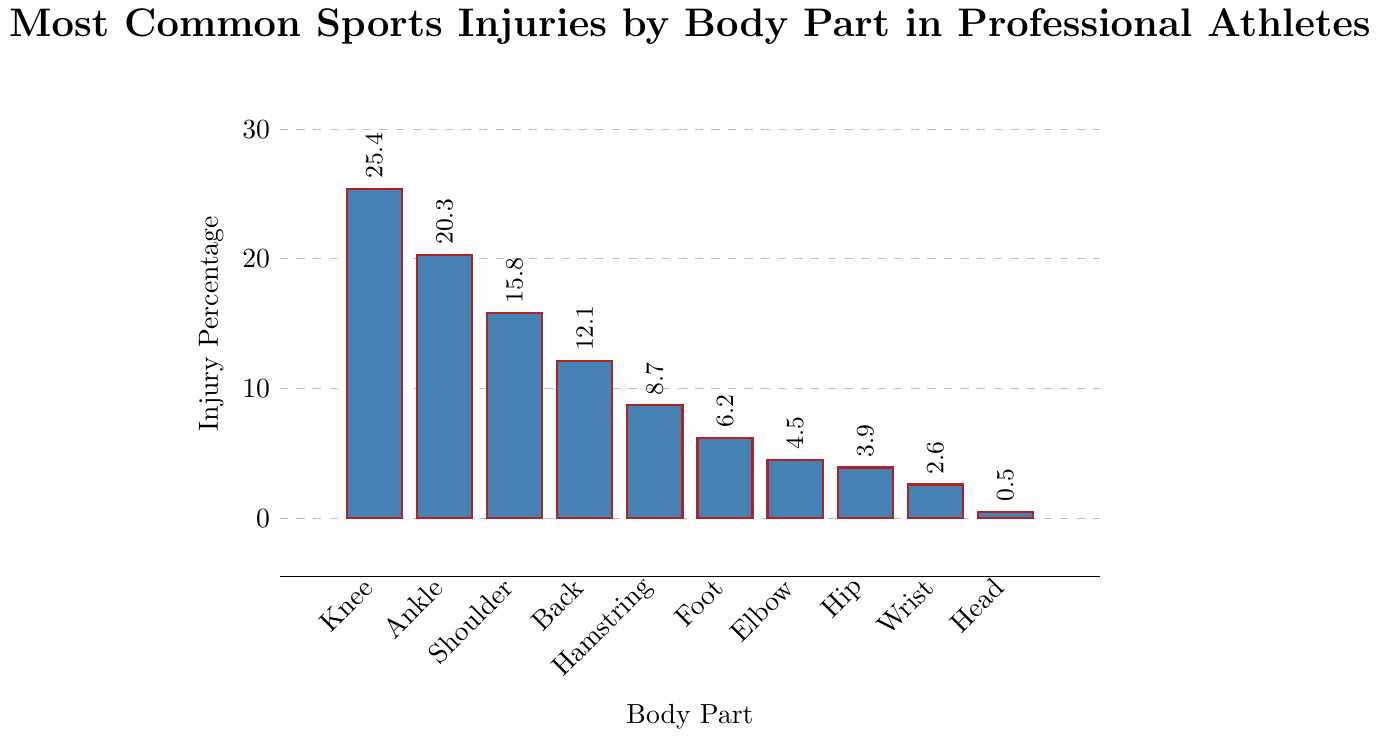Which body part has the highest percentage of injuries? The tallest bar in the chart represents the body part with the highest injury percentage. This bar is labeled "Knee".
Answer: Knee What's the combined percentage of ankle and shoulder injuries? Find the percentages for ankle and shoulder on the y-axis, which are 20.3% and 15.8%, respectively. Adding these together: 20.3 + 15.8 = 36.1%
Answer: 36.1% Which body part has a higher injury percentage: elbow or wrist? Compare the heights of the bars representing elbow and wrist injuries. The elbow is 4.5%, and the wrist is 2.6%. Since 4.5% is greater than 2.6%, the elbow has a higher injury percentage.
Answer: Elbow By how much does the knee injury percentage exceed the average injury percentage for all listed body parts? First calculate the average injury percentage: (25.4 + 20.3 + 15.8 + 12.1 + 8.7 + 6.2 + 4.5 + 3.9 + 2.6 + 0.5) / 10 = 10%. Then, subtract the average from the knee injury percentage: 25.4 - 10 = 15.4%.
Answer: 15.4% What is the percentage difference between the most and least common injuries? Find the percentages of the most common (knee, 25.4%) and least common (head, 0.5%) injuries, then subtract the latter from the former: 25.4 - 0.5 = 24.9%
Answer: 24.9% Are back injuries more common than hamstring injuries? Compare the heights of the bars for back injuries and hamstring injuries. The back injury percentage is 12.1%, and the hamstring injury percentage is 8.7%. Since 12.1% is greater than 8.7%, back injuries are more common.
Answer: Yes What's the percentage of injuries for the three least injured body parts combined? Identify the three least injured body parts: hip (3.9%), wrist (2.6%), head (0.5%). Sum these percentages: 3.9 + 2.6 + 0.5 = 7%.
Answer: 7% What is the median injury percentage? List the injury percentages in ascending order: 0.5, 2.6, 3.9, 4.5, 6.2, 8.7, 12.1, 15.8, 20.3, 25.4. The median value, being the middle of sorted values, is between 6.2 and 8.7. Therefore, the median is (6.2 + 8.7) / 2 = 7.45%.
Answer: 7.45% Is the injury percentage for the hip closer to that of the elbow or foot? Compare the injury percentages of hip (3.9%), elbow (4.5%), and foot (6.2%). The difference between hip and elbow is 4.5 - 3.9 = 0.6. The difference between hip and foot is 6.2 - 3.9 = 2.3. Since 0.6 is less than 2.3, the hip injury percentage is closer to that of the elbow.
Answer: Elbow 